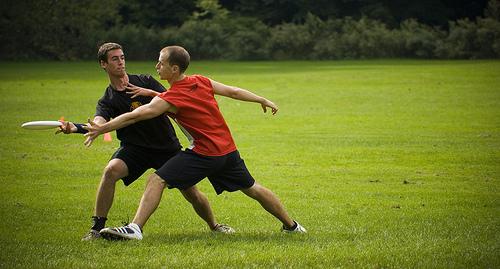What color is his shirt?
Write a very short answer. Red. What color shirt is the man in front wearing?
Write a very short answer. Red. Which arm of the boy is lowered? right or left?
Short answer required. Left. What is the white disk called?
Keep it brief. Frisbee. What is the sport they are playing called?
Quick response, please. Frisbee. 